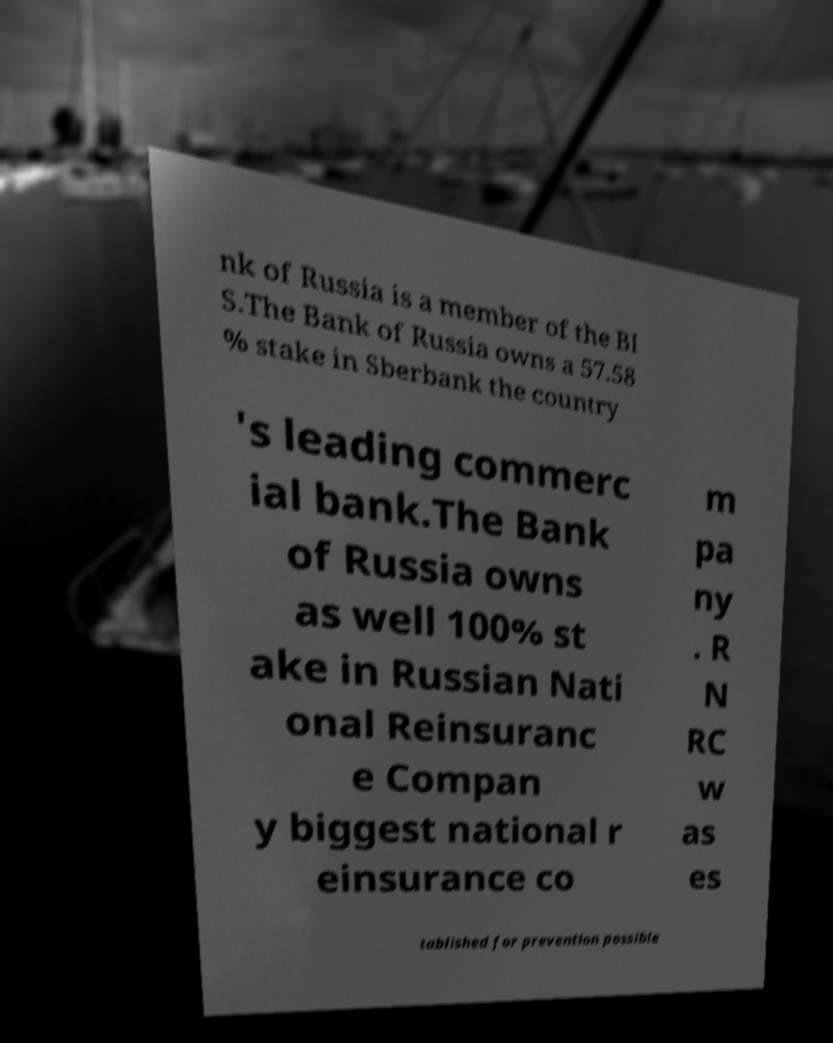Please identify and transcribe the text found in this image. nk of Russia is a member of the BI S.The Bank of Russia owns a 57.58 % stake in Sberbank the country 's leading commerc ial bank.The Bank of Russia owns as well 100% st ake in Russian Nati onal Reinsuranc e Compan y biggest national r einsurance co m pa ny . R N RC w as es tablished for prevention possible 